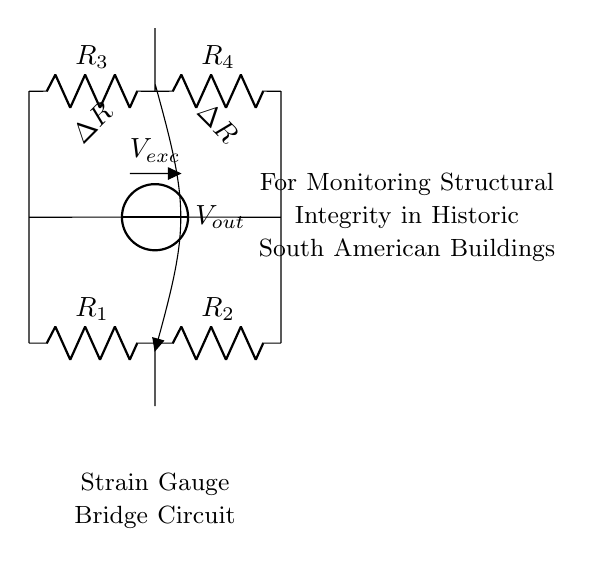What type of circuit is this? This is a bridge circuit, specifically a strain gauge bridge, which consists of resistors arranged in a diamond shape to measure small changes in resistance.
Answer: bridge circuit What does V exc represent in this circuit? V exc is the excitation voltage supplied to the bridge circuit to provide the necessary power for measuring resistance changes.
Answer: excitation voltage How many resistors are in the circuit? There are four resistors, denoted as R1, R2, R3, and R4, used for balancing the bridge and detecting changes due to strain.
Answer: four What is the purpose of the strain gauges in the circuit? The strain gauges measure the deformation of the building structure by detecting changes in resistance due to strain, providing information on structural integrity.
Answer: measure deformation What is V out used for in this circuit? V out is the output voltage that indicates the imbalance in the bridge and reflects the changes in resistance caused by strain in the structure.
Answer: output voltage What happens if one of the resistors in the bridge changes value? If one of the resistors changes, it causes a voltage imbalance across the circuit, which alters V out, indicating a change in strain.
Answer: causes voltage imbalance What are the two gauges represented in the circuit? The two gauges are represented by the change in resistance symbols, indicating that they respond to strain in opposite directions for accurate measurement.
Answer: change in resistance 